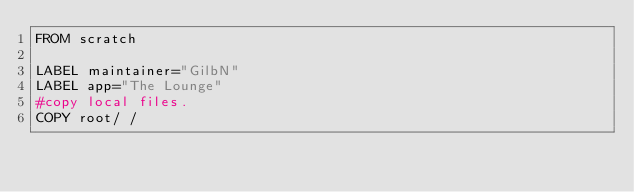Convert code to text. <code><loc_0><loc_0><loc_500><loc_500><_Dockerfile_>FROM scratch

LABEL maintainer="GilbN" 
LABEL app="The Lounge"
#copy local files.  
COPY root/ /</code> 